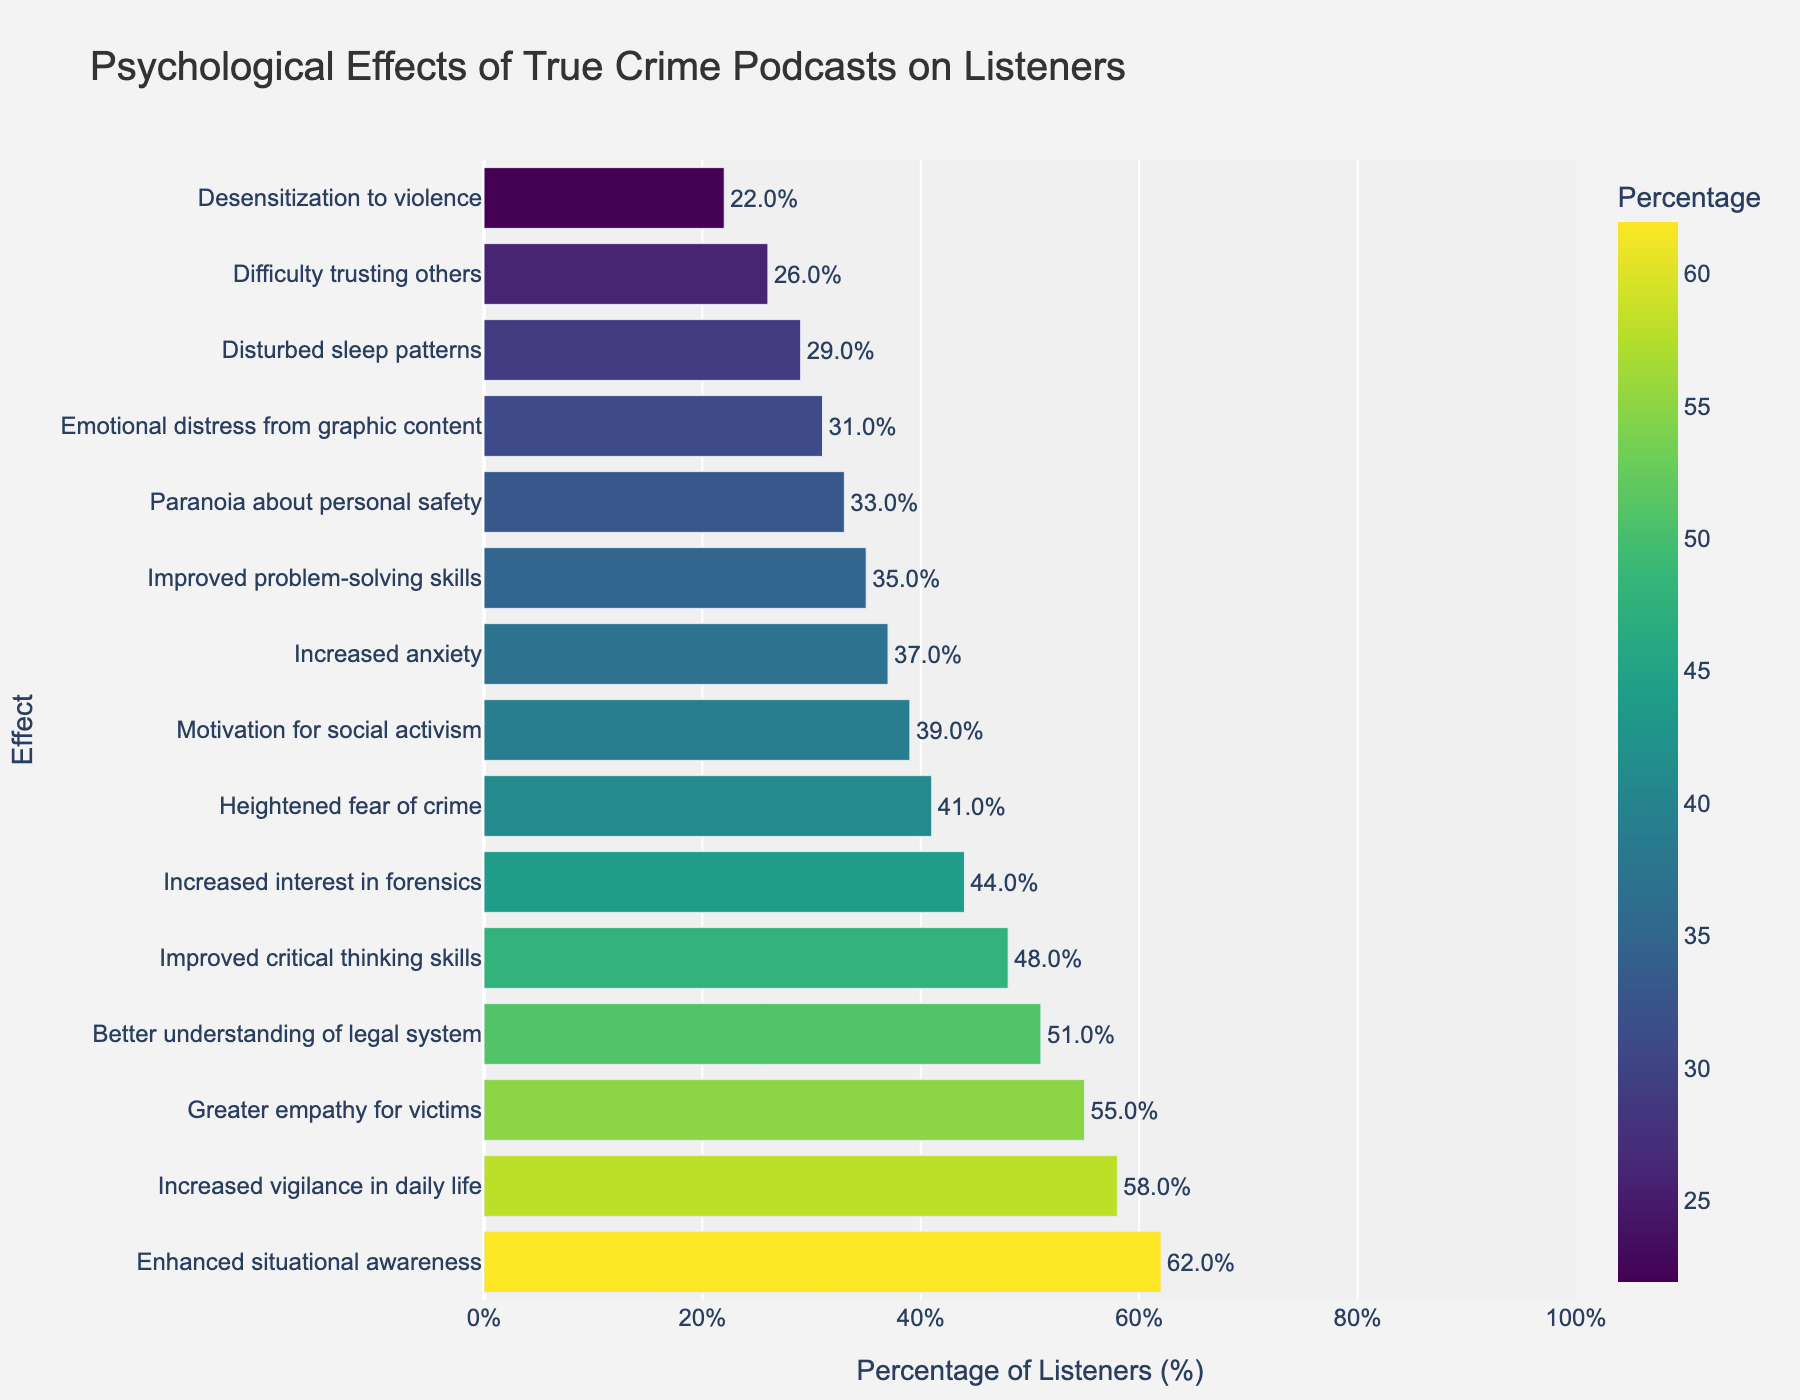What is the most common psychological effect of true crime podcasts on listeners? The bar with the highest percentage represents the most common effect. Enhanced situational awareness has the highest percentage at 62%.
Answer: Enhanced situational awareness Which psychological effect has the lowest percentage amongst the listed impacts? The shortest bar indicates the lowest percentage. Desensitization to violence has the lowest percentage at 22%.
Answer: Desensitization to violence How does the percentage of listeners experiencing increased anxiety compare to those with greater empathy for victims? Compare the heights of the respective bars. Increased anxiety is at 37%, while greater empathy for victims is at 55%.
Answer: Greater empathy for victims Which psychological effects have more than 50% of listeners reporting them? Identify the bars with percentages greater than 50%. They are enhanced situational awareness (62%) and better understanding of legal system (51%).
Answer: Enhanced situational awareness and better understanding of legal system How many psychological effects are reported by more than 40% but less than 60% of listeners? Count the bars within the 40-60% range: improved critical thinking skills (48%), greater empathy for victims (55%), heightened fear of crime (41%), increased interest in forensics (44%), increased vigilance in daily life (58%), and better understanding of legal system (51%). There are 6 impacts.
Answer: 6 Which impact type is closer in percentage to "Paranoia about personal safety": "Increased interest in forensics" or "Improved problem-solving skills"? Compare the percentages: paranoia about personal safety (33%), increased interest in forensics (44%), and improved problem-solving skills (35%). Improved problem-solving skills (35%) is closer to 33% than increased interest in forensics (44%).
Answer: Improved problem-solving skills What is the combined percentage of listeners reporting disturbed sleep patterns, emotional distress from graphic content, and difficulty trusting others? Add the percentages for each of these effects: disturbed sleep patterns (29%), emotional distress from graphic content (31%), and difficulty trusting others (26%). The combined percentage is 29% + 31% + 26% = 86%.
Answer: 86% Which effect has almost the same percentage of listeners reporting it as "Motivation for social activism"? Compare the percentages for the closest match: motivation for social activism (39%) is closest to improved problem-solving skills (35%).
Answer: Improved problem-solving skills Is the percentage of listeners experiencing heightened fear of crime greater than the percentage experiencing paranoia about personal safety? Compare the percentages of the two effects: heightened fear of crime (41%) vs. paranoia about personal safety (33%). 41% > 33%.
Answer: Yes What is the average percentage of listeners experiencing disturbed sleep patterns, increased anxiety, and difficulty trusting others? Calculate the average: (29% + 37% + 26%) / 3 = 92% / 3 ≈ 30.67%.
Answer: Approximately 31% 